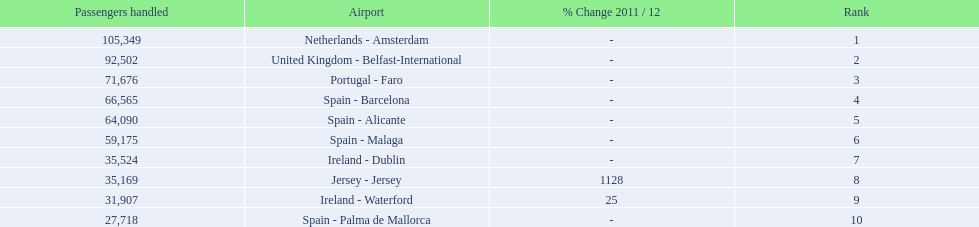How many passengers did the united kingdom handle? 92,502. Who handled more passengers than this? Netherlands - Amsterdam. 